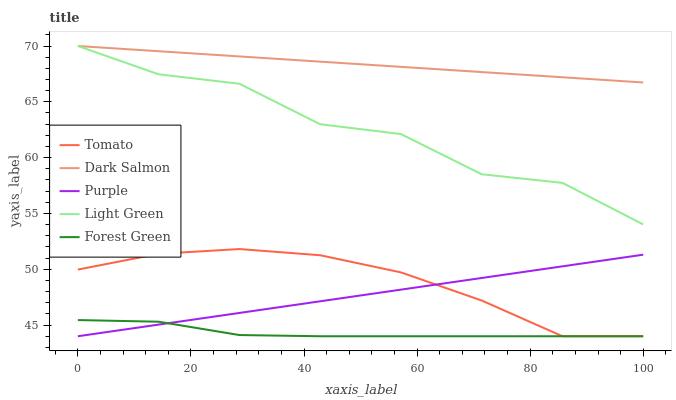Does Purple have the minimum area under the curve?
Answer yes or no. No. Does Purple have the maximum area under the curve?
Answer yes or no. No. Is Forest Green the smoothest?
Answer yes or no. No. Is Forest Green the roughest?
Answer yes or no. No. Does Dark Salmon have the lowest value?
Answer yes or no. No. Does Purple have the highest value?
Answer yes or no. No. Is Tomato less than Dark Salmon?
Answer yes or no. Yes. Is Light Green greater than Forest Green?
Answer yes or no. Yes. Does Tomato intersect Dark Salmon?
Answer yes or no. No. 